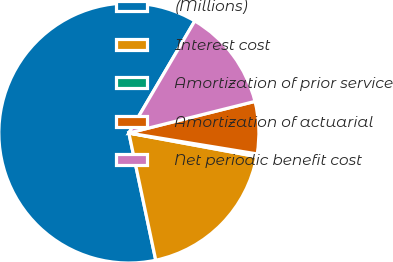Convert chart to OTSL. <chart><loc_0><loc_0><loc_500><loc_500><pie_chart><fcel>(Millions)<fcel>Interest cost<fcel>Amortization of prior service<fcel>Amortization of actuarial<fcel>Net periodic benefit cost<nl><fcel>61.78%<fcel>18.77%<fcel>0.34%<fcel>6.48%<fcel>12.63%<nl></chart> 